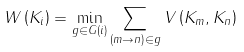Convert formula to latex. <formula><loc_0><loc_0><loc_500><loc_500>W \left ( K _ { i } \right ) = \min _ { g \in G \left ( i \right ) } \sum _ { \left ( m \rightarrow n \right ) \in g } V \left ( K _ { m } , K _ { n } \right )</formula> 